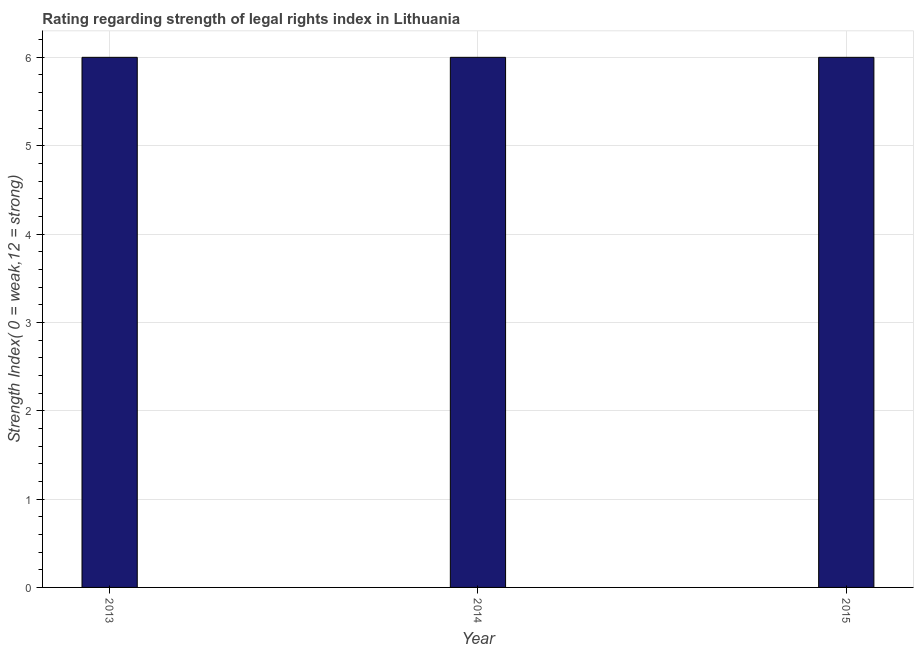Does the graph contain grids?
Provide a short and direct response. Yes. What is the title of the graph?
Keep it short and to the point. Rating regarding strength of legal rights index in Lithuania. What is the label or title of the X-axis?
Your response must be concise. Year. What is the label or title of the Y-axis?
Make the answer very short. Strength Index( 0 = weak,12 = strong). What is the strength of legal rights index in 2014?
Your answer should be very brief. 6. Across all years, what is the minimum strength of legal rights index?
Offer a very short reply. 6. In which year was the strength of legal rights index maximum?
Give a very brief answer. 2013. What is the sum of the strength of legal rights index?
Keep it short and to the point. 18. What is the difference between the strength of legal rights index in 2013 and 2014?
Provide a succinct answer. 0. What is the average strength of legal rights index per year?
Ensure brevity in your answer.  6. What is the median strength of legal rights index?
Offer a very short reply. 6. In how many years, is the strength of legal rights index greater than 2.6 ?
Keep it short and to the point. 3. What is the ratio of the strength of legal rights index in 2013 to that in 2015?
Give a very brief answer. 1. What is the difference between the highest and the second highest strength of legal rights index?
Keep it short and to the point. 0. Is the sum of the strength of legal rights index in 2013 and 2015 greater than the maximum strength of legal rights index across all years?
Provide a succinct answer. Yes. What is the difference between the highest and the lowest strength of legal rights index?
Provide a succinct answer. 0. In how many years, is the strength of legal rights index greater than the average strength of legal rights index taken over all years?
Make the answer very short. 0. Are all the bars in the graph horizontal?
Make the answer very short. No. What is the ratio of the Strength Index( 0 = weak,12 = strong) in 2013 to that in 2015?
Make the answer very short. 1. 